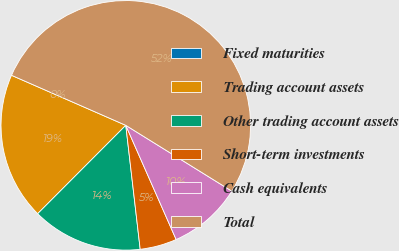<chart> <loc_0><loc_0><loc_500><loc_500><pie_chart><fcel>Fixed maturities<fcel>Trading account assets<fcel>Other trading account assets<fcel>Short-term investments<fcel>Cash equivalents<fcel>Total<nl><fcel>0.0%<fcel>19.09%<fcel>14.32%<fcel>4.77%<fcel>9.55%<fcel>52.27%<nl></chart> 